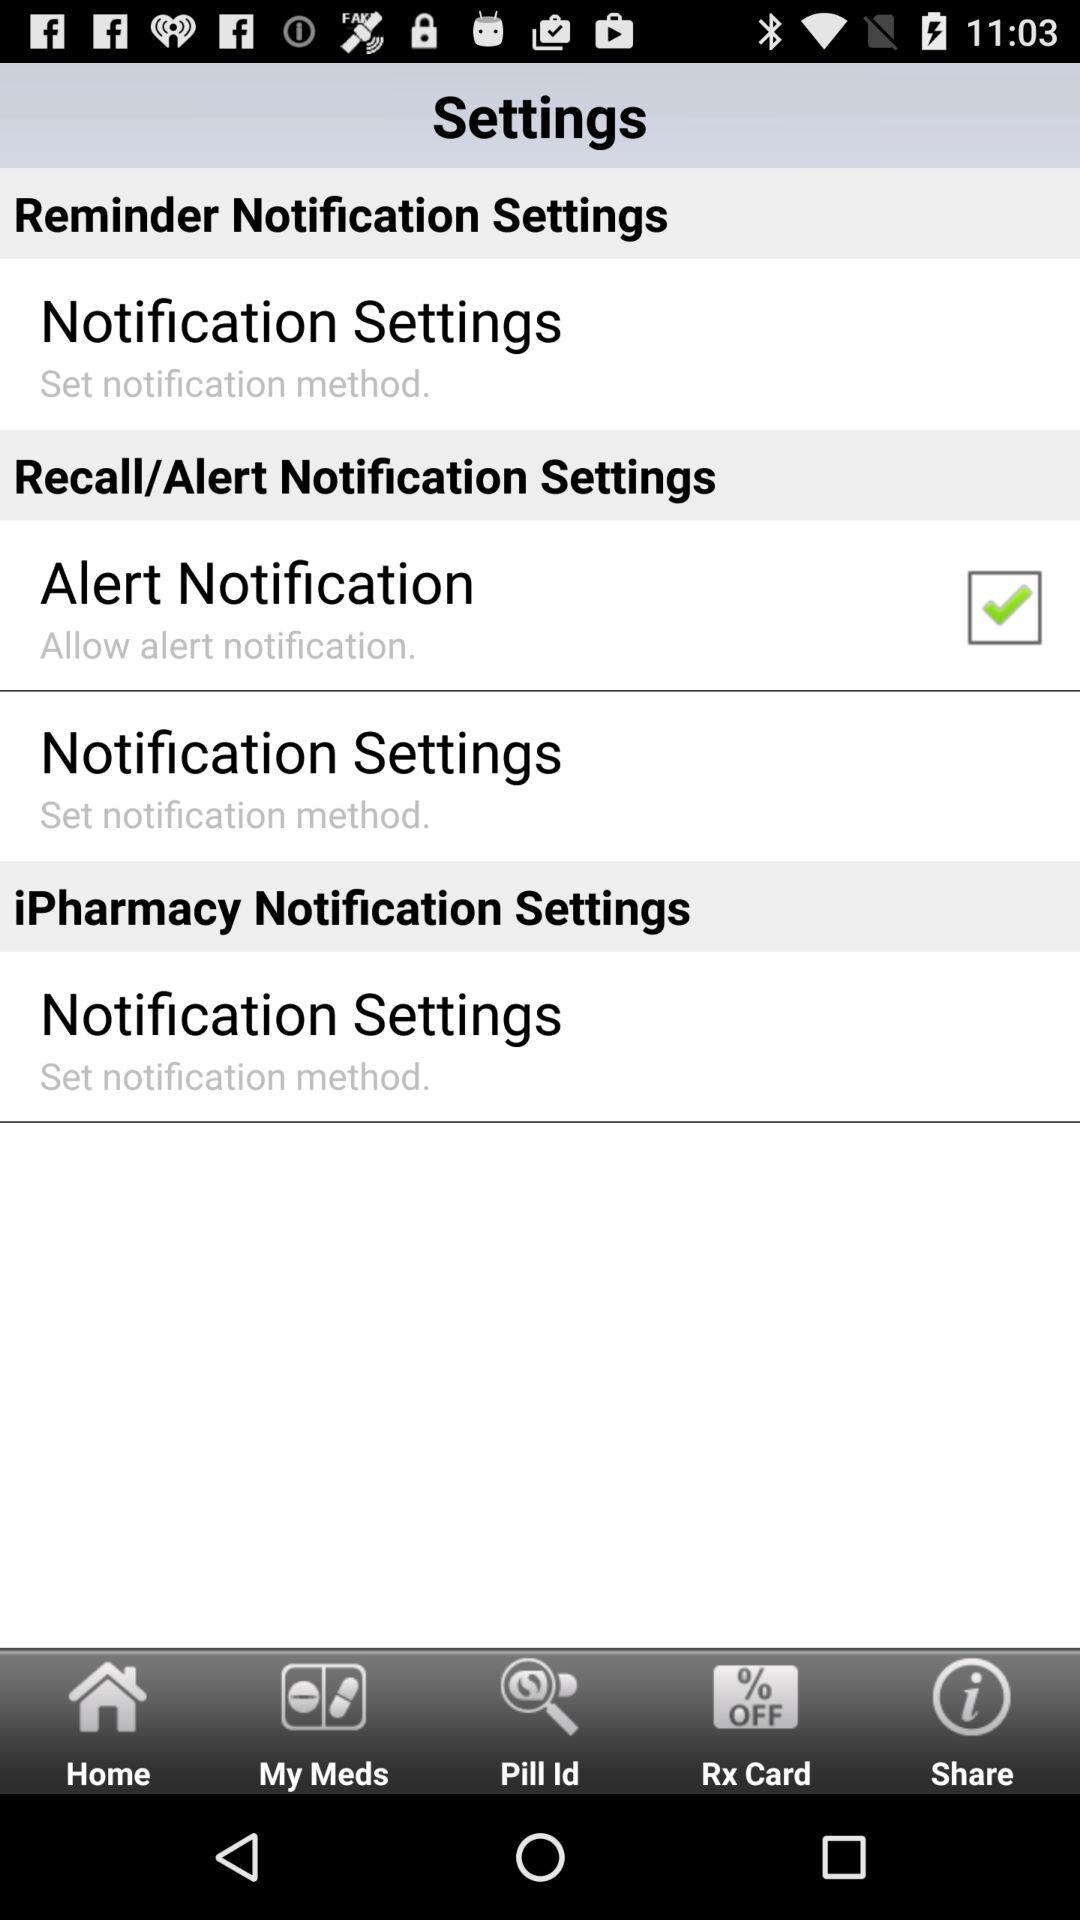How many more reminder notification settings are there than iPharmacy notification settings?
Answer the question using a single word or phrase. 2 